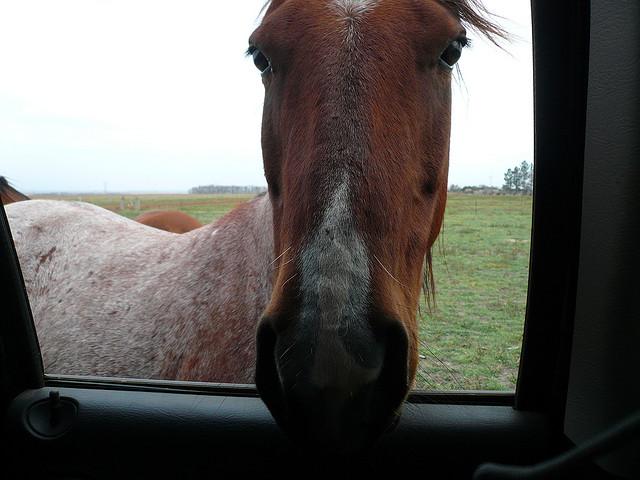Is there a beak on this animal?
Concise answer only. No. What is the name of this animal in the image?
Answer briefly. Horse. What color is the animals eyes?
Short answer required. Brown. What animal is shown on the left?
Keep it brief. Horse. How many animals are there?
Answer briefly. 1. Which animal is depicted?
Short answer required. Horse. What is the type of environment shown in the photo?
Quick response, please. Field. What is the color of the grass?
Write a very short answer. Green. Is the horse in the car?
Give a very brief answer. Yes. What is the person in the car taking a picture of?
Keep it brief. Horse. What vehicle can be seen outside?
Quick response, please. Horse. Is this a dog?
Keep it brief. No. What animal is this?
Quick response, please. Horse. 